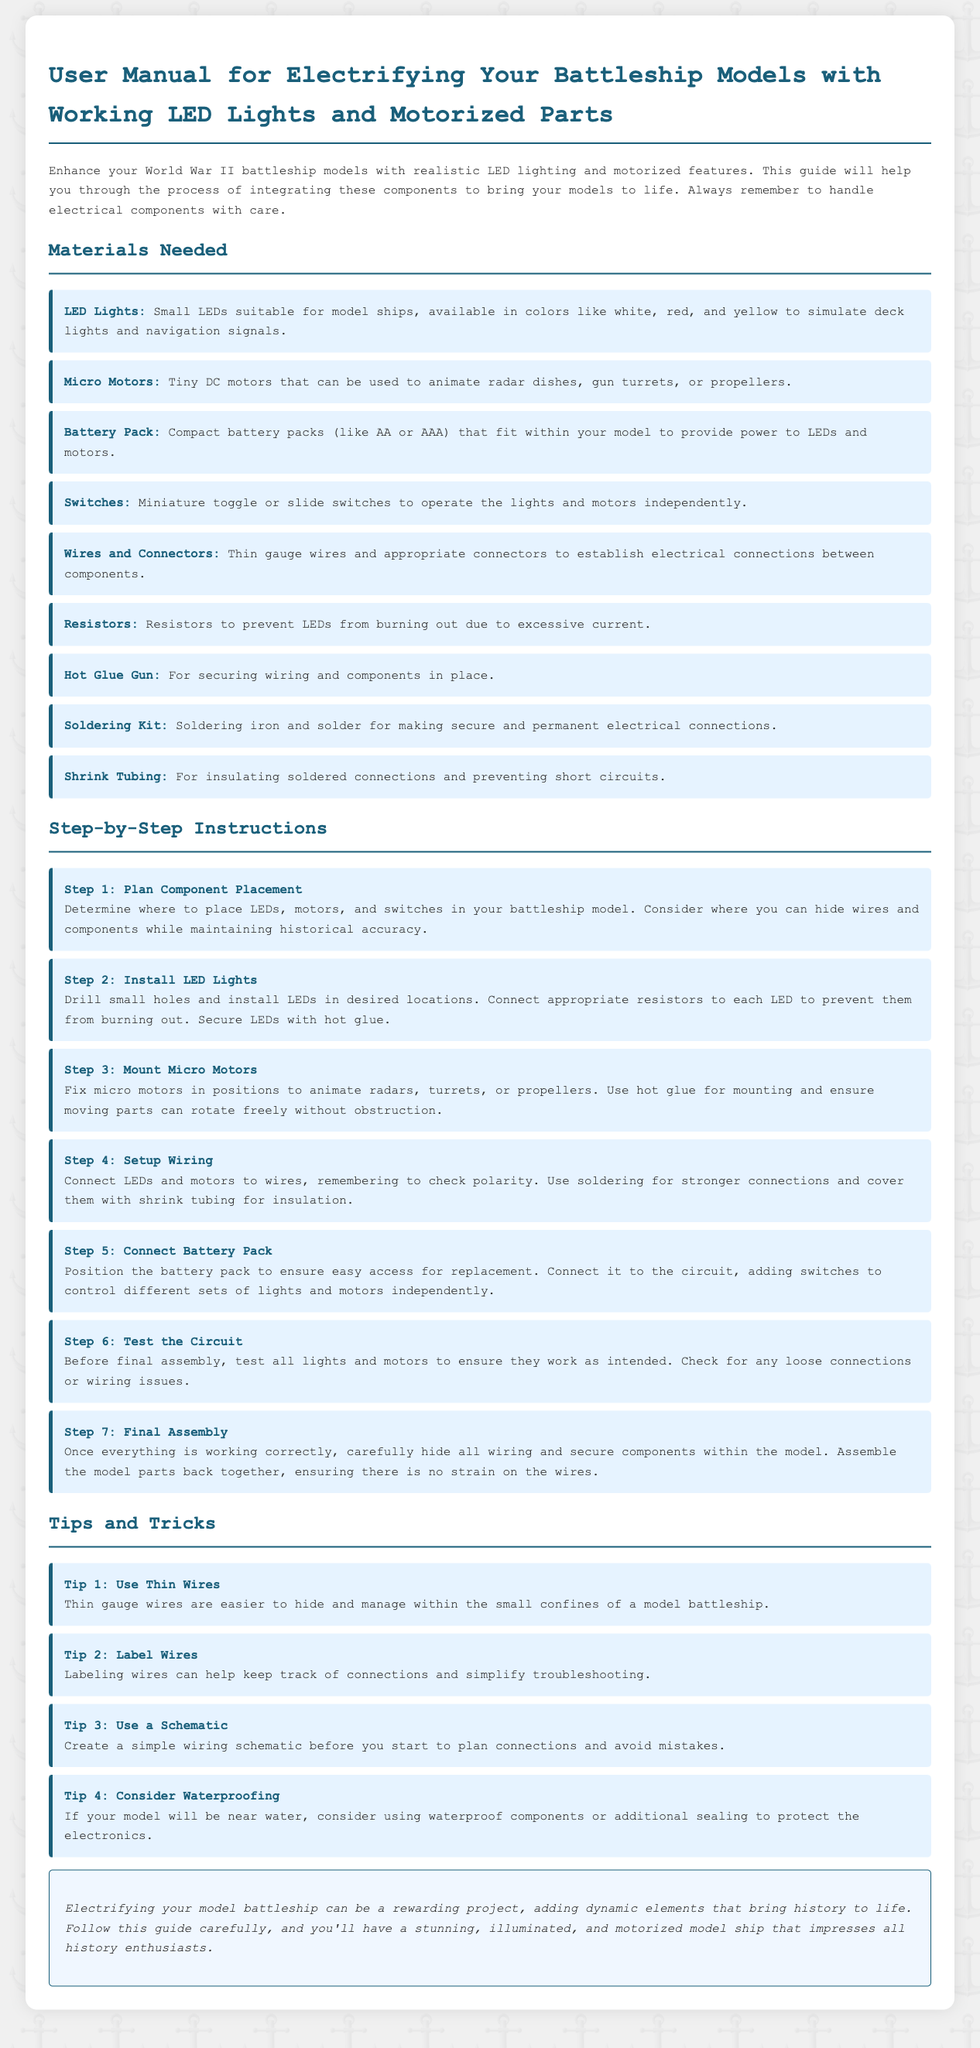what materials are needed for installation? The materials listed include LED Lights, Micro Motors, Battery Pack, Switches, Wires and Connectors, Resistors, Hot Glue Gun, Soldering Kit, and Shrink Tubing.
Answer: LED Lights, Micro Motors, Battery Pack, Switches, Wires and Connectors, Resistors, Hot Glue Gun, Soldering Kit, Shrink Tubing how many steps are in the installation instructions? The document outlines a total of seven steps for the installation process.
Answer: 7 what is the first step in the instructions? The first step in the installation process is to "Plan Component Placement."
Answer: Plan Component Placement why is it important to connect a resistor to each LED? A resistor is needed to prevent LEDs from burning out due to excessive current.
Answer: To prevent LEDs from burning out what are two types of switches recommended? The document recommends using miniature toggle or slide switches for operations.
Answer: Miniature toggle or slide switches how should wires be managed according to the tips section? The document suggests labeling wires to help keep track of connections and simplify troubleshooting.
Answer: Labeling wires what is the purpose of shrink tubing? Shrink tubing is used for insulating soldered connections and preventing short circuits.
Answer: Insulating soldered connections what should be checked before final assembly? Before final assembly, all lights and motors should be tested to ensure they work.
Answer: Test all lights and motors what is a recommended practice if the model is near water? It is advised to consider waterproofing components to protect the electronics.
Answer: Waterproofing components 